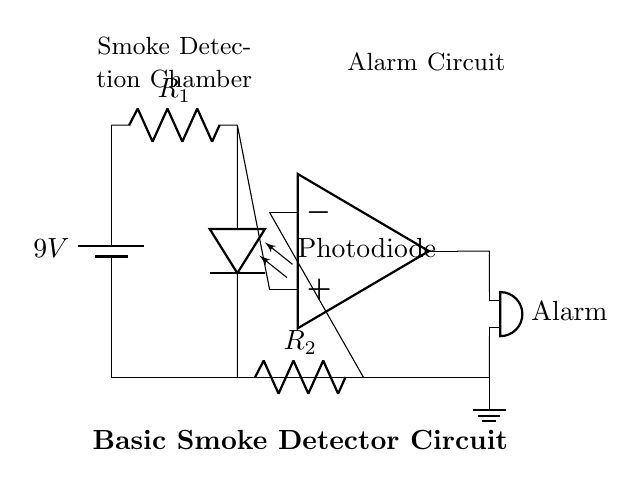What is the voltage of the power supply in this circuit? The circuit shows a battery labeled with a voltage of 9 volts, indicating the potential difference provided by the power supply.
Answer: 9 volts What type of sensor is used in this circuit? The circuit diagram features a component labeled "Photodiode," indicating that a photoelectric sensor is used to detect smoke.
Answer: Photodiode How many resistors are present in the circuit? The diagram shows two resistors labeled R1 and R2, confirming that there are two resistors in this smoke detector circuit.
Answer: Two What connects the photodiode to the comparator? The circuit connects the photodiode to the positive input of the op amp (comparator) through the resistor R1, establishing a pathway for the signal generated by the photodiode.
Answer: Resistor R1 What triggers the alarm in this smoke detector circuit? The photodiode generates a signal that, when it reaches a certain level, the output of the op amp (comparator) activates the buzzer alarm, indicating smoke detection.
Answer: Output of the op amp What is the purpose of the resistors R1 and R2 in this circuit? Resistor R1 is part of the path for the signal from the photodiode to the comparator, while resistor R2 is connected to the negative input of the op amp, helping to set the reference voltage for comparison. Together, they help in determining when the alarm should trigger based on the smoke density detected.
Answer: Signal conditioning and reference voltage 